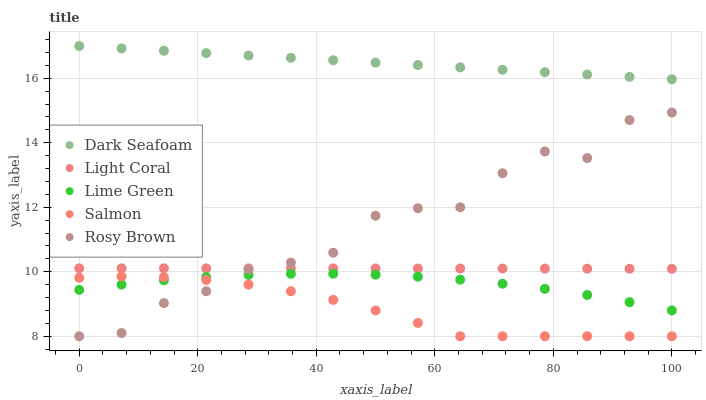Does Salmon have the minimum area under the curve?
Answer yes or no. Yes. Does Dark Seafoam have the maximum area under the curve?
Answer yes or no. Yes. Does Dark Seafoam have the minimum area under the curve?
Answer yes or no. No. Does Salmon have the maximum area under the curve?
Answer yes or no. No. Is Dark Seafoam the smoothest?
Answer yes or no. Yes. Is Rosy Brown the roughest?
Answer yes or no. Yes. Is Salmon the smoothest?
Answer yes or no. No. Is Salmon the roughest?
Answer yes or no. No. Does Salmon have the lowest value?
Answer yes or no. Yes. Does Dark Seafoam have the lowest value?
Answer yes or no. No. Does Dark Seafoam have the highest value?
Answer yes or no. Yes. Does Salmon have the highest value?
Answer yes or no. No. Is Lime Green less than Dark Seafoam?
Answer yes or no. Yes. Is Light Coral greater than Lime Green?
Answer yes or no. Yes. Does Salmon intersect Rosy Brown?
Answer yes or no. Yes. Is Salmon less than Rosy Brown?
Answer yes or no. No. Is Salmon greater than Rosy Brown?
Answer yes or no. No. Does Lime Green intersect Dark Seafoam?
Answer yes or no. No. 